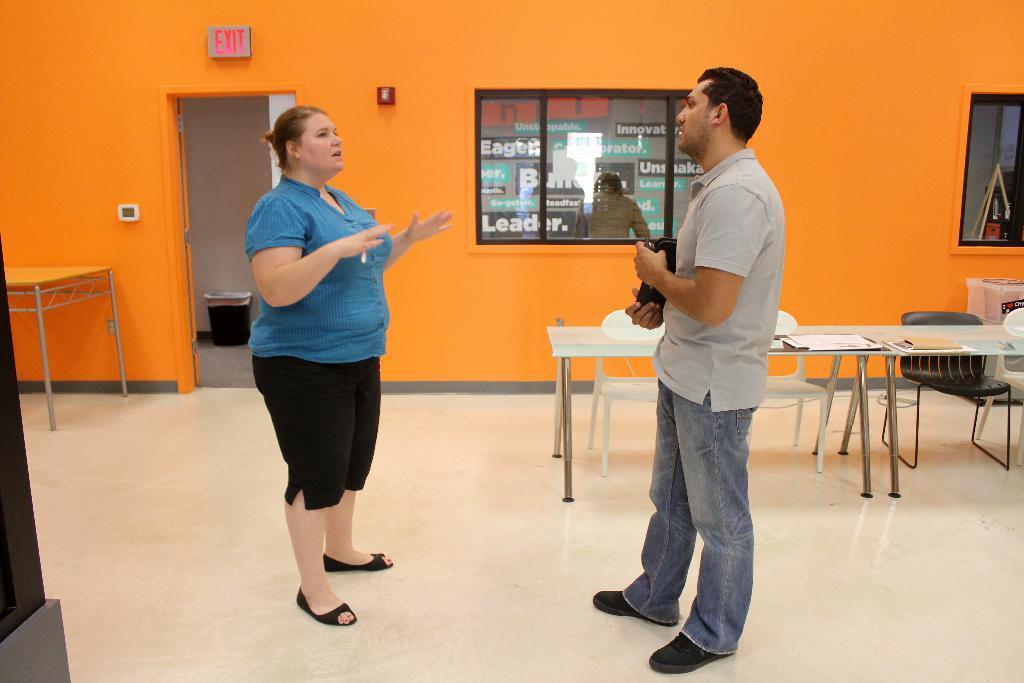Please provide a concise description of this image. This picture is taken in a room. There are women and a man. Women in the left side wearing a blue top and black trousers. A man towards the right, he is wearing a grey shirt, blue jeans and holding a file. Towards the right corner there is a table and some papers on it and there are some chairs towards the right. Towards the left there is another table and a door besides that. In the center there is a window. 